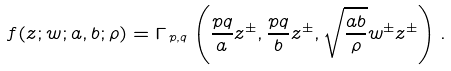Convert formula to latex. <formula><loc_0><loc_0><loc_500><loc_500>f ( z ; w ; a , b ; \rho ) = \Gamma _ { \, p , q } \left ( \frac { p q } { a } z ^ { \pm } , \frac { p q } { b } z ^ { \pm } , \sqrt { \frac { a b } { \rho } } w ^ { \pm } z ^ { \pm } \right ) .</formula> 